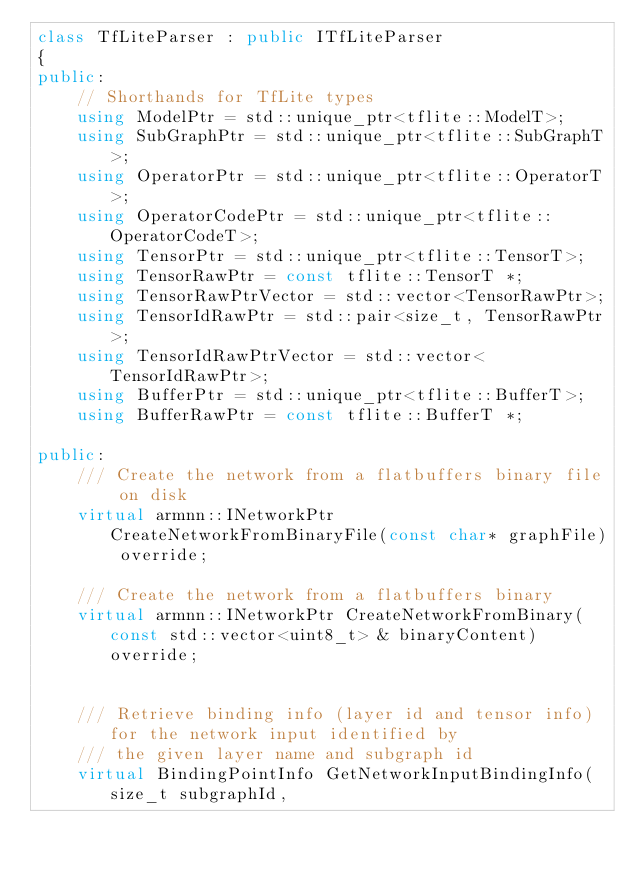Convert code to text. <code><loc_0><loc_0><loc_500><loc_500><_C++_>class TfLiteParser : public ITfLiteParser
{
public:
    // Shorthands for TfLite types
    using ModelPtr = std::unique_ptr<tflite::ModelT>;
    using SubGraphPtr = std::unique_ptr<tflite::SubGraphT>;
    using OperatorPtr = std::unique_ptr<tflite::OperatorT>;
    using OperatorCodePtr = std::unique_ptr<tflite::OperatorCodeT>;
    using TensorPtr = std::unique_ptr<tflite::TensorT>;
    using TensorRawPtr = const tflite::TensorT *;
    using TensorRawPtrVector = std::vector<TensorRawPtr>;
    using TensorIdRawPtr = std::pair<size_t, TensorRawPtr>;
    using TensorIdRawPtrVector = std::vector<TensorIdRawPtr>;
    using BufferPtr = std::unique_ptr<tflite::BufferT>;
    using BufferRawPtr = const tflite::BufferT *;

public:
    /// Create the network from a flatbuffers binary file on disk
    virtual armnn::INetworkPtr CreateNetworkFromBinaryFile(const char* graphFile) override;

    /// Create the network from a flatbuffers binary
    virtual armnn::INetworkPtr CreateNetworkFromBinary(const std::vector<uint8_t> & binaryContent) override;


    /// Retrieve binding info (layer id and tensor info) for the network input identified by
    /// the given layer name and subgraph id
    virtual BindingPointInfo GetNetworkInputBindingInfo(size_t subgraphId,</code> 